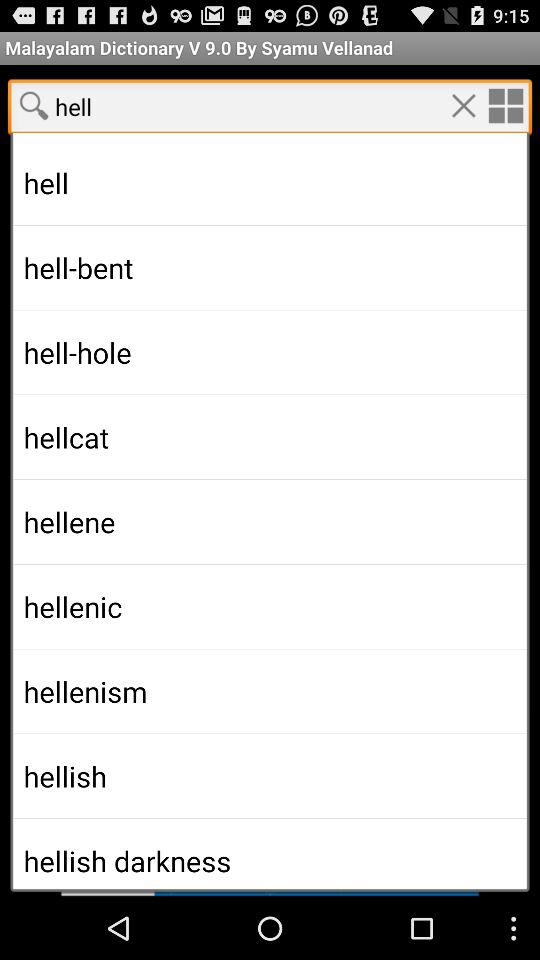What is the type of Malayalam dictionary?
When the provided information is insufficient, respond with <no answer>. <no answer> 